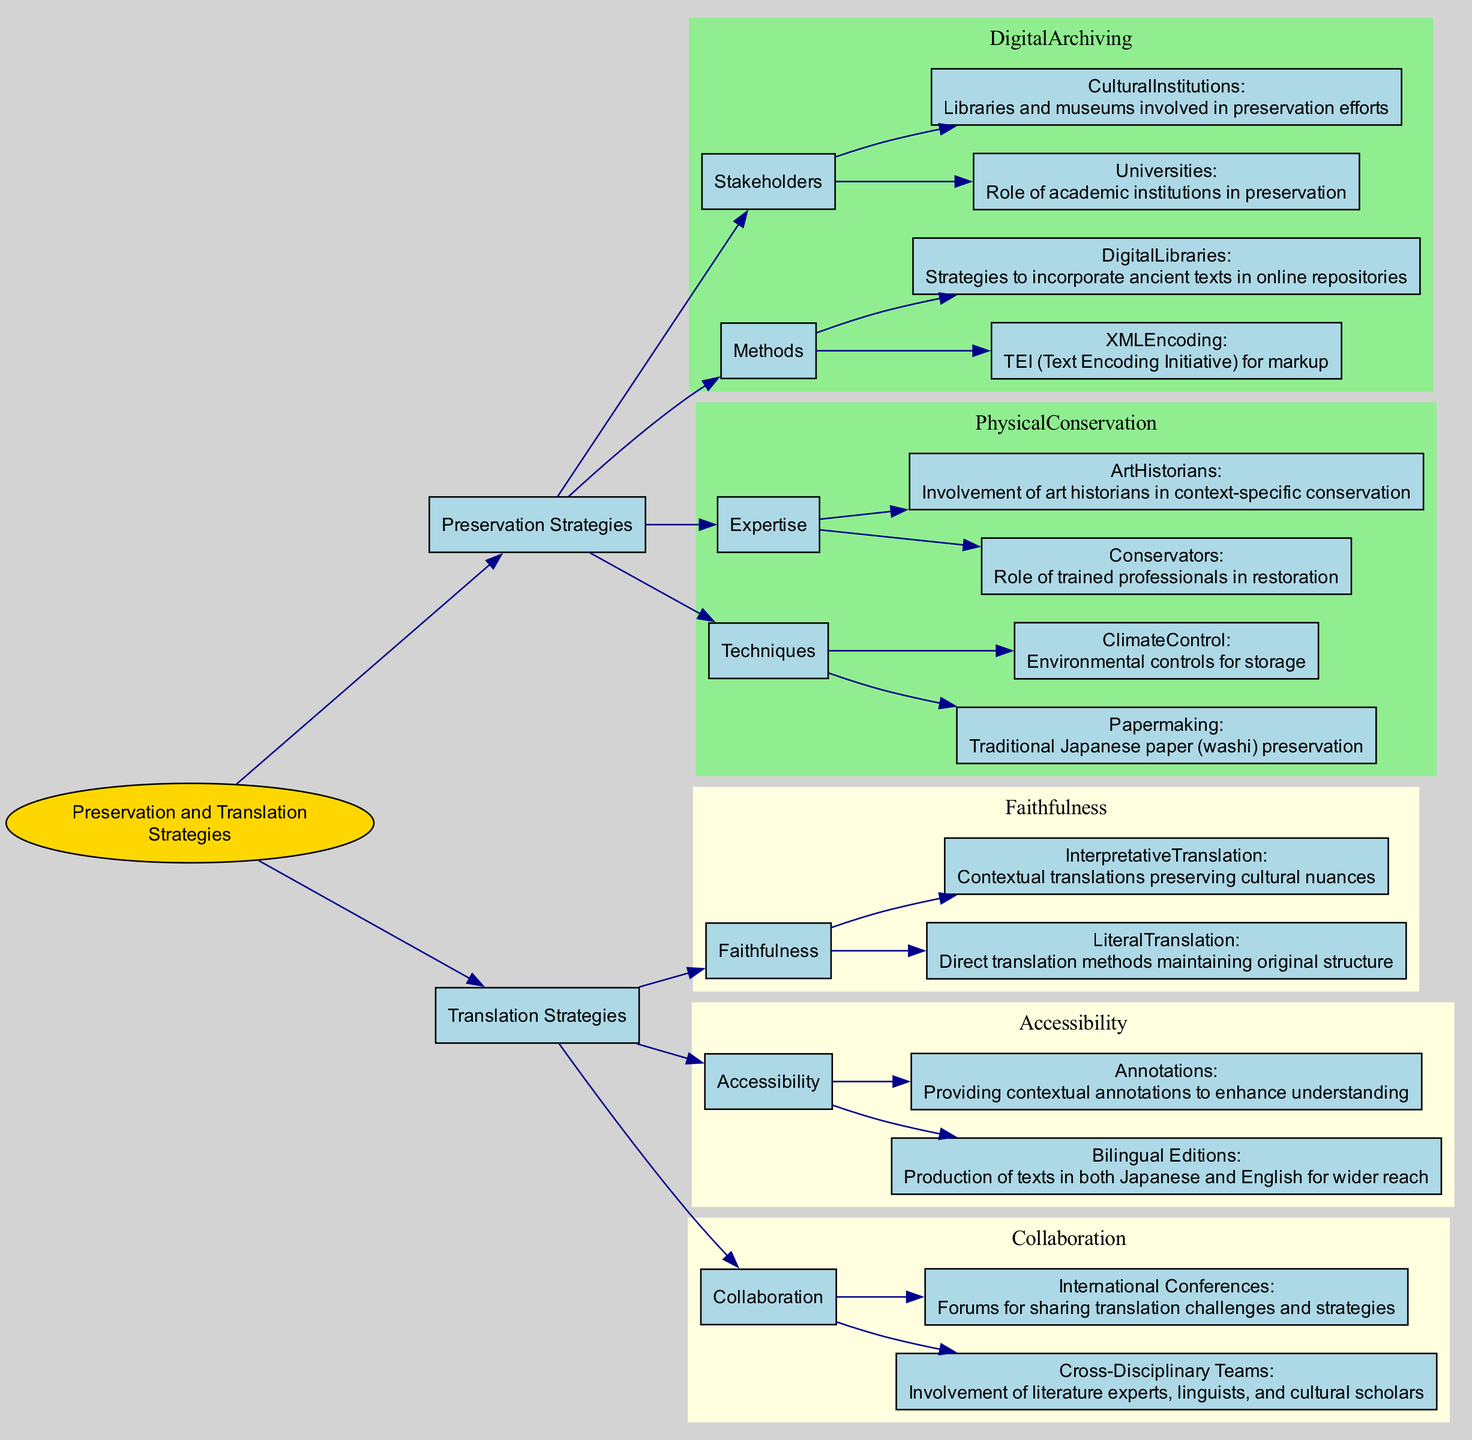What are the two main categories of strategies in the diagram? The diagram clearly indicates that the root node splits into two main branches: "Preservation Strategies" and "Translation Strategies." These are the two primary categories highlighted in the decision tree.
Answer: Preservation Strategies, Translation Strategies How many methods are listed under Preservation Strategies? Upon examining the "Preservation Strategies" section, there are two primary methods mentioned: "Digital Archiving" and "Physical Conservation." Thus, the total number is two.
Answer: 2 Which digital archiving method specifically mentions the use of markup? Within the "Digital Archiving" section, the method specifically mentioning markup is "XMLEncoding," which relates to the Text Encoding Initiative (TEI). This is the only method that includes such a reference.
Answer: XMLEncoding What is the role of conservators in physical conservation? In the "Physical Conservation" category under "Expertise," the role of conservators is described as "Role of trained professionals in restoration." This succinctly summarizes their contribution to physical preservation.
Answer: Role of trained professionals in restoration Which translation strategy involves producing bilingual editions? The "Accessibility" category within the "Translation Strategies" explicitly notes "Bilingual Editions" as a method that focuses on creating texts in both Japanese and English. This directly answers the query related to translation strategies.
Answer: Bilingual Editions How do collaboration strategies enhance translation efforts? When reviewing the "Collaboration" category in "Translation Strategies," both "Cross-Disciplinary Teams" and "International Conferences" are mentioned. These collaborations involve various experts, which aids in addressing translation challenges and sharing insights among scholars.
Answer: Involvement of literature experts, linguists, and cultural scholars Which technique is highlighted for traditional Japanese paper preservation? Under "Physical Conservation" in the "Techniques" section, "Papermaking" is specifically noted for traditional Japanese paper (washi) preservation, detailing a unique preservation method relevant to ancient texts.
Answer: Papermaking What is the goal of providing annotations in translation strategies? The diagram states that annotations aim to "Enhance understanding" within the "Accessibility" category of "Translation Strategies." This indicates that such contextual additions serve to improve the reader's grasp of the translated text.
Answer: Enhance understanding How many main strategies are listed under Translation Strategies? In the "Translation Strategies" section, three main strategies are highlighted: "Faithfulness," "Accessibility," and "Collaboration." Therefore, the total count of main strategies in this category is three.
Answer: 3 